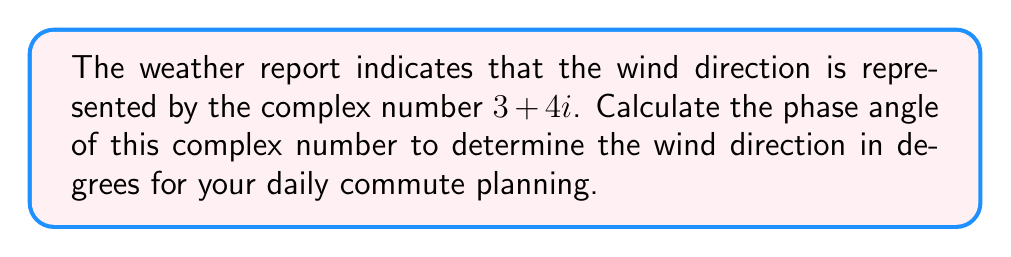Can you answer this question? To calculate the phase angle of a complex number $z = a + bi$, we use the arctangent function:

$$\theta = \arctan\left(\frac{b}{a}\right)$$

where $\theta$ is the phase angle in radians.

Given the complex number $3 + 4i$:

1. Identify the real part $a = 3$ and the imaginary part $b = 4$.

2. Calculate the ratio $\frac{b}{a}$:
   $$\frac{b}{a} = \frac{4}{3}$$

3. Apply the arctangent function:
   $$\theta = \arctan\left(\frac{4}{3}\right)$$

4. Evaluate the arctangent:
   $$\theta \approx 0.9272952180 \text{ radians}$$

5. Convert radians to degrees:
   $$\theta_{\text{degrees}} = \theta_{\text{radians}} \times \frac{180°}{\pi}$$
   $$\theta_{\text{degrees}} \approx 0.9272952180 \times \frac{180°}{\pi} \approx 53.13010235°$$

6. Round to two decimal places for practical use:
   $$\theta_{\text{degrees}} \approx 53.13°$$

This angle represents the wind direction measured counterclockwise from the positive x-axis (East).
Answer: $53.13°$ 